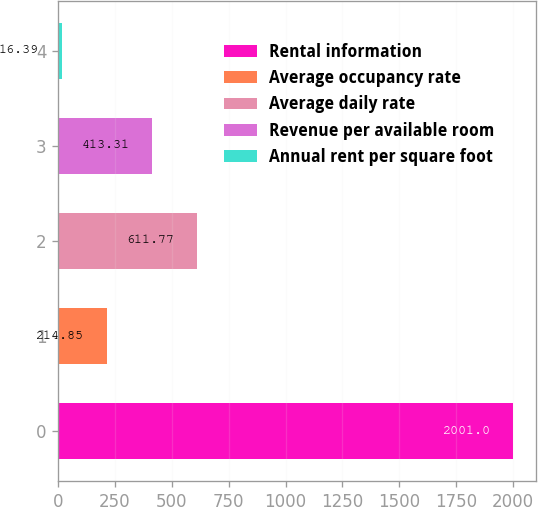<chart> <loc_0><loc_0><loc_500><loc_500><bar_chart><fcel>Rental information<fcel>Average occupancy rate<fcel>Average daily rate<fcel>Revenue per available room<fcel>Annual rent per square foot<nl><fcel>2001<fcel>214.85<fcel>611.77<fcel>413.31<fcel>16.39<nl></chart> 